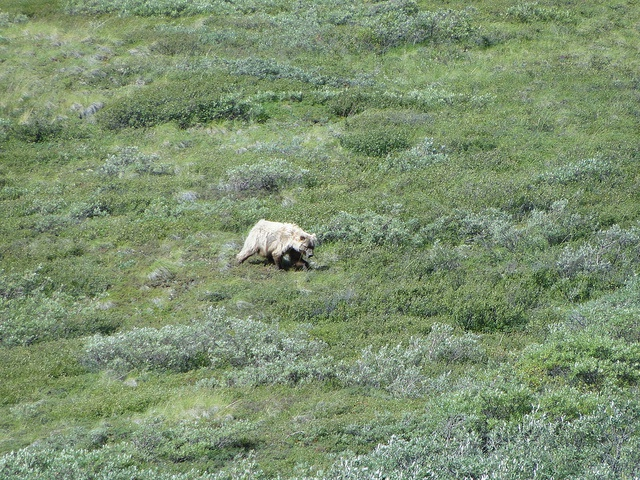Describe the objects in this image and their specific colors. I can see a bear in olive, lightgray, black, darkgray, and gray tones in this image. 